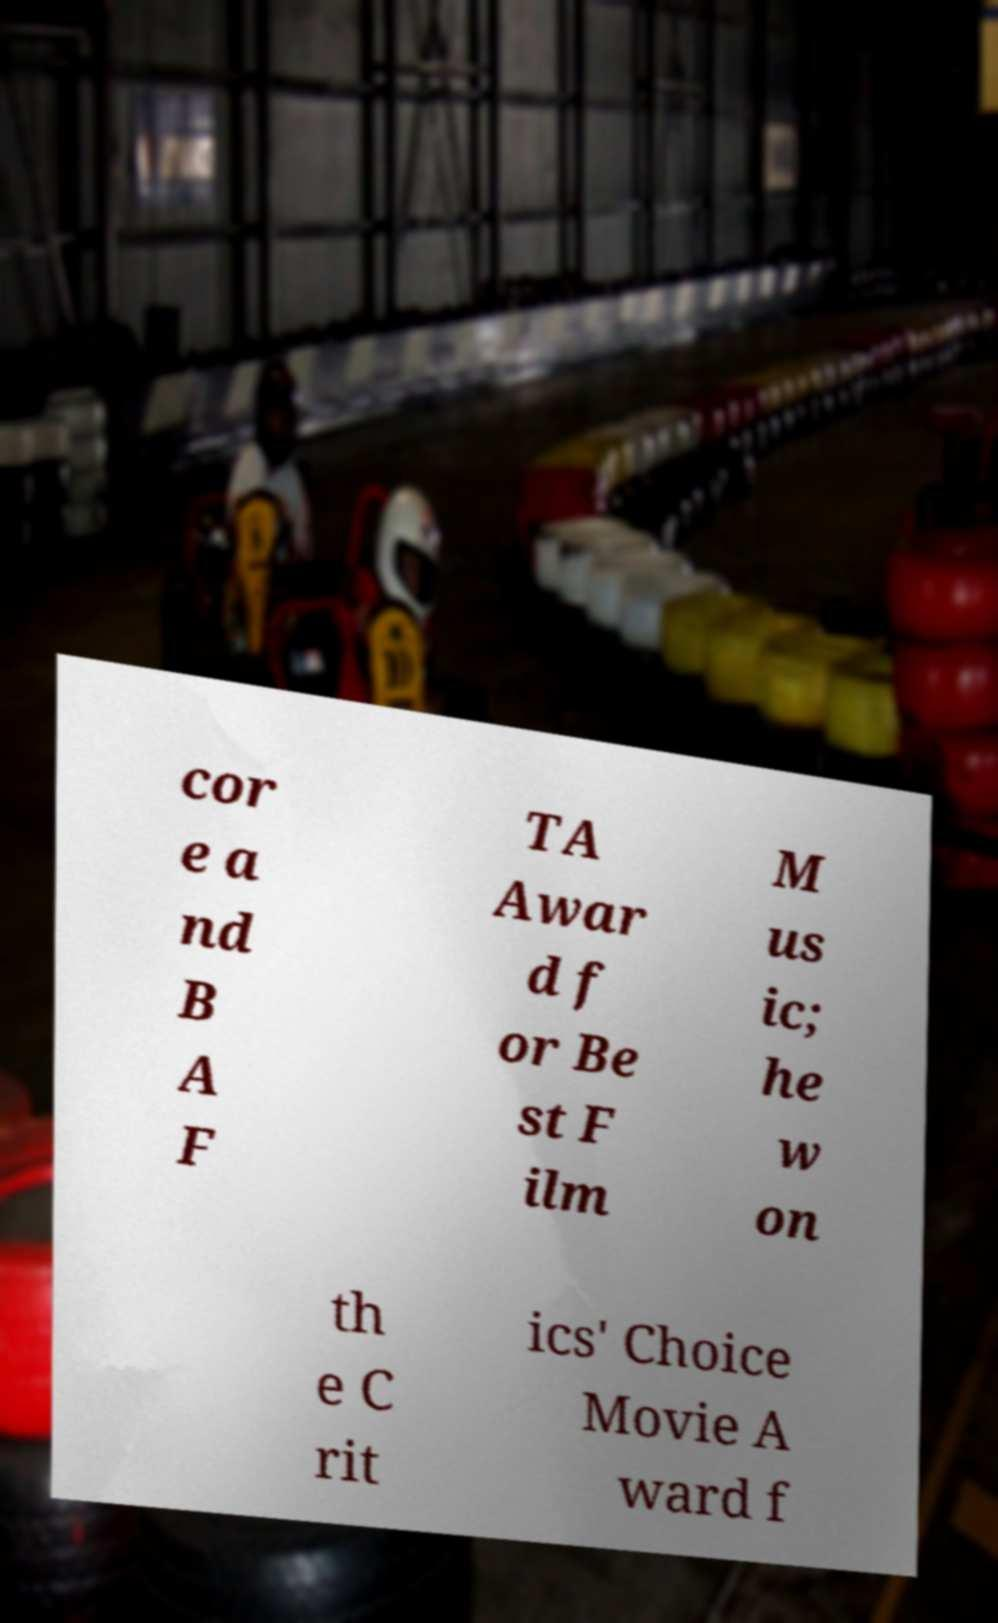Please read and relay the text visible in this image. What does it say? cor e a nd B A F TA Awar d f or Be st F ilm M us ic; he w on th e C rit ics' Choice Movie A ward f 